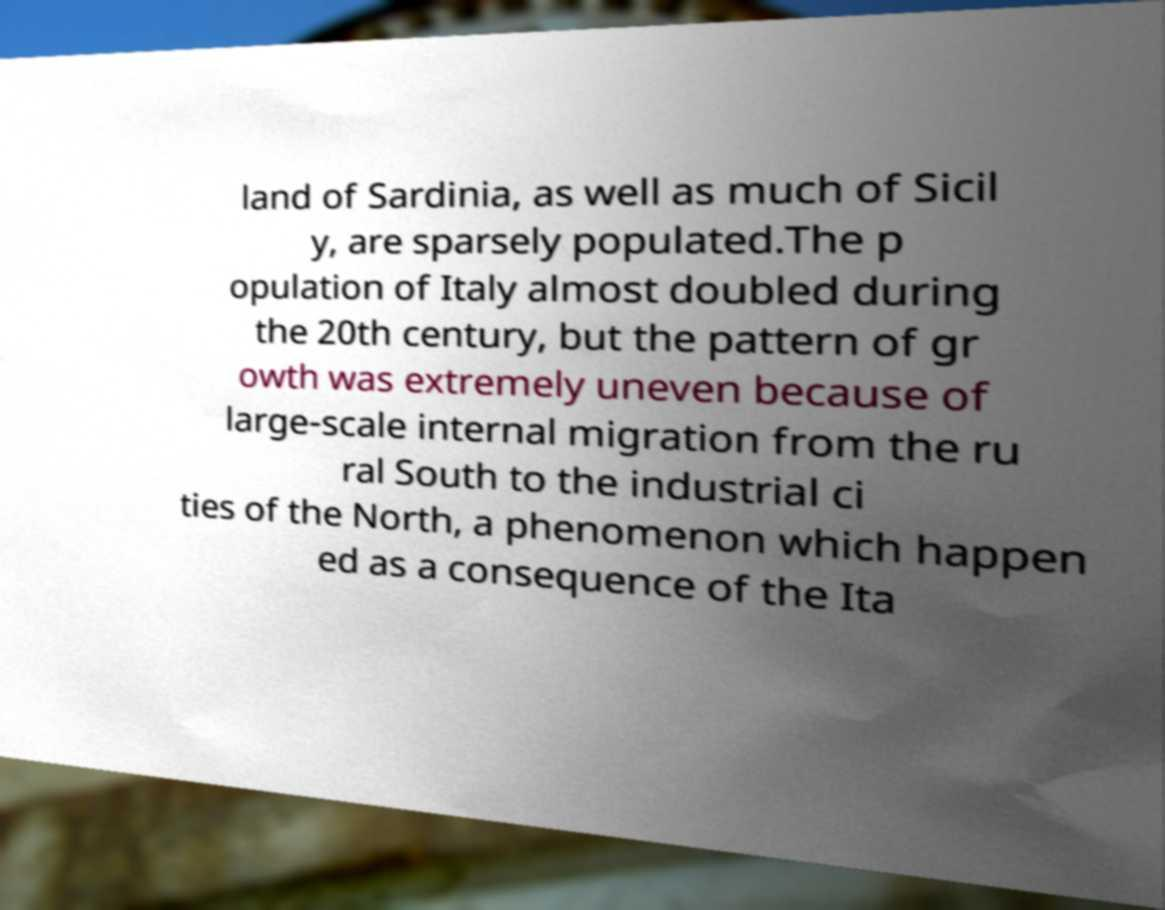There's text embedded in this image that I need extracted. Can you transcribe it verbatim? land of Sardinia, as well as much of Sicil y, are sparsely populated.The p opulation of Italy almost doubled during the 20th century, but the pattern of gr owth was extremely uneven because of large-scale internal migration from the ru ral South to the industrial ci ties of the North, a phenomenon which happen ed as a consequence of the Ita 